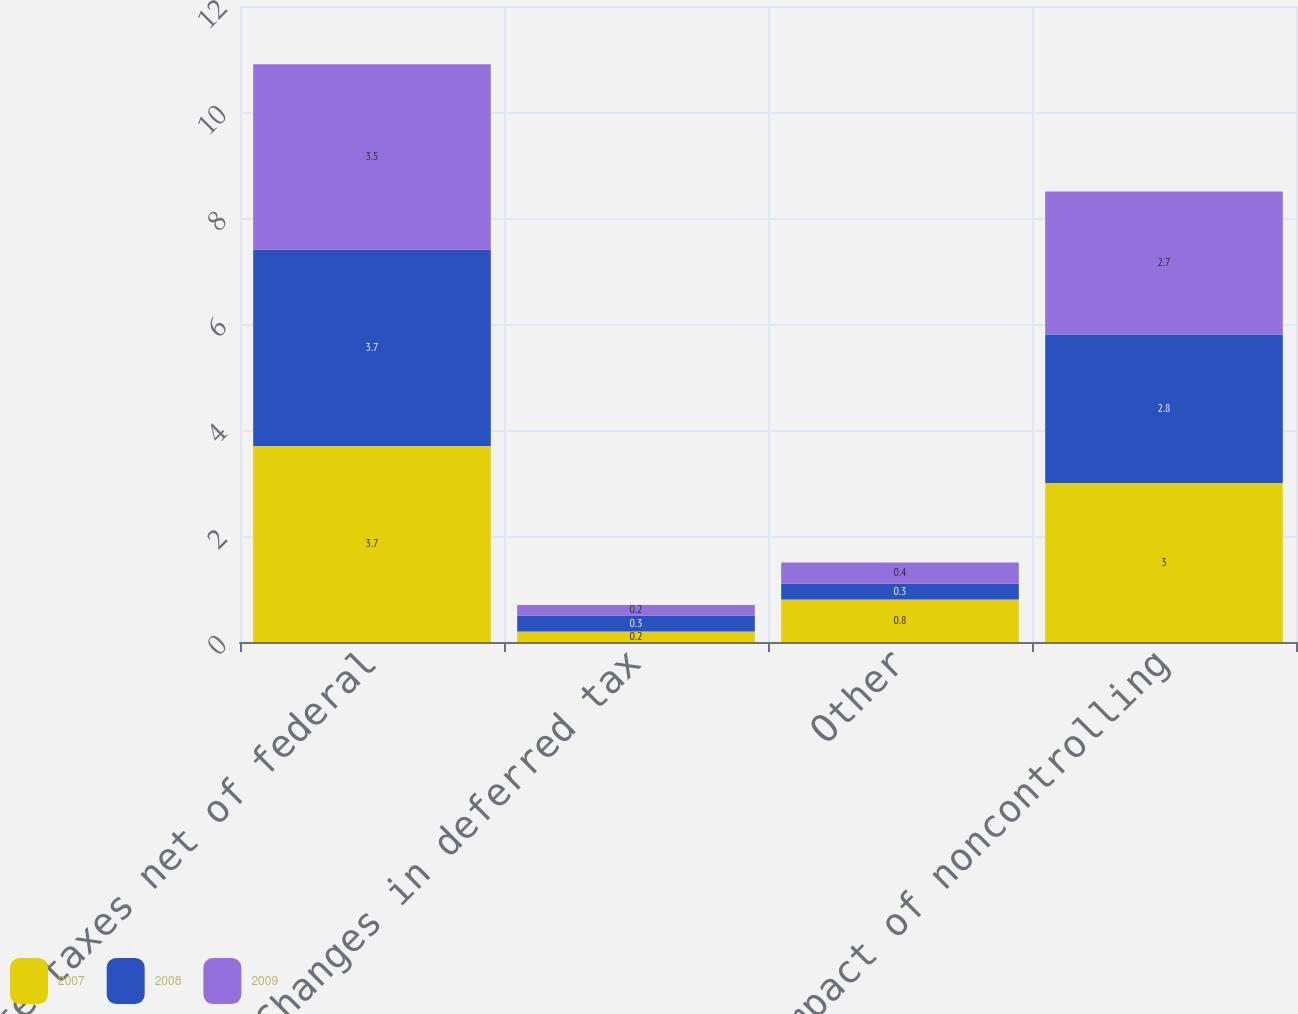<chart> <loc_0><loc_0><loc_500><loc_500><stacked_bar_chart><ecel><fcel>State taxes net of federal<fcel>Changes in deferred tax<fcel>Other<fcel>Impact of noncontrolling<nl><fcel>2007<fcel>3.7<fcel>0.2<fcel>0.8<fcel>3<nl><fcel>2008<fcel>3.7<fcel>0.3<fcel>0.3<fcel>2.8<nl><fcel>2009<fcel>3.5<fcel>0.2<fcel>0.4<fcel>2.7<nl></chart> 